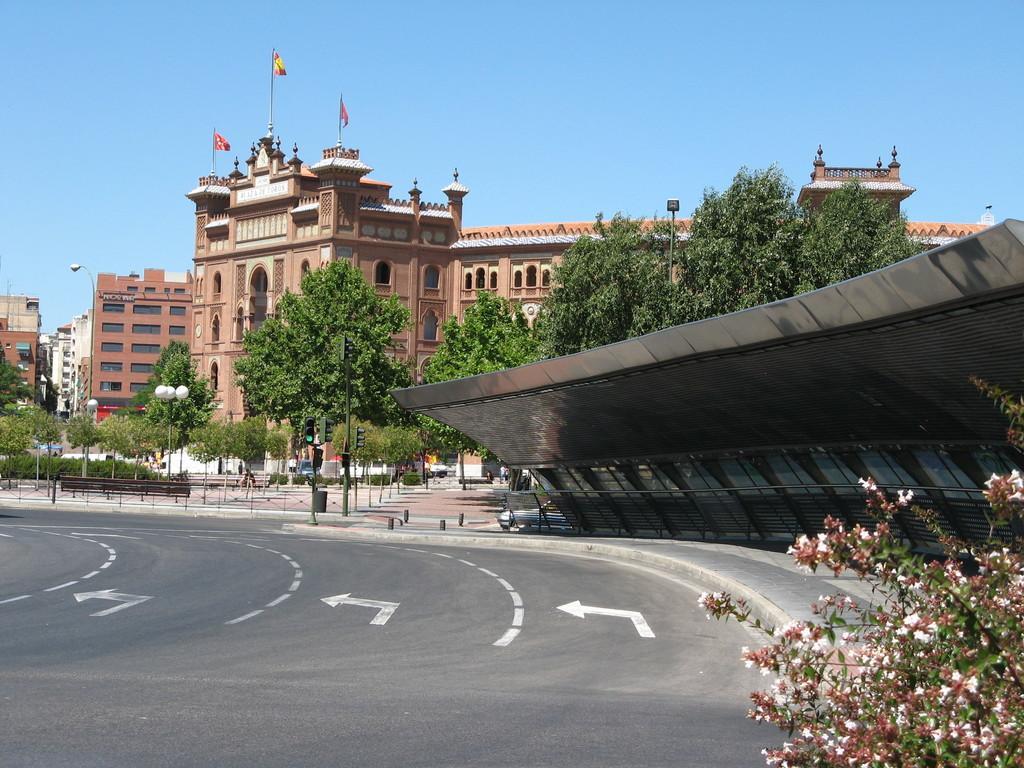In one or two sentences, can you explain what this image depicts? At the bottom of the image, we can see the road, plant and flowers. Here it looks like a shed and walkway. Background we can see so many trees, buildings, walls, street lights, traffic signals, poles and few objects. Top of the image, there is the sky and flags. 